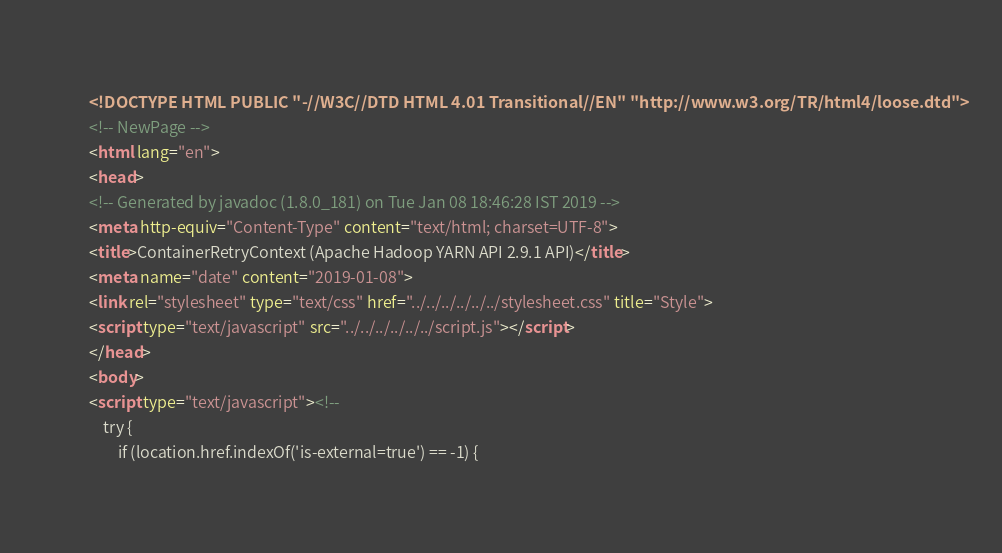Convert code to text. <code><loc_0><loc_0><loc_500><loc_500><_HTML_><!DOCTYPE HTML PUBLIC "-//W3C//DTD HTML 4.01 Transitional//EN" "http://www.w3.org/TR/html4/loose.dtd">
<!-- NewPage -->
<html lang="en">
<head>
<!-- Generated by javadoc (1.8.0_181) on Tue Jan 08 18:46:28 IST 2019 -->
<meta http-equiv="Content-Type" content="text/html; charset=UTF-8">
<title>ContainerRetryContext (Apache Hadoop YARN API 2.9.1 API)</title>
<meta name="date" content="2019-01-08">
<link rel="stylesheet" type="text/css" href="../../../../../../stylesheet.css" title="Style">
<script type="text/javascript" src="../../../../../../script.js"></script>
</head>
<body>
<script type="text/javascript"><!--
    try {
        if (location.href.indexOf('is-external=true') == -1) {</code> 